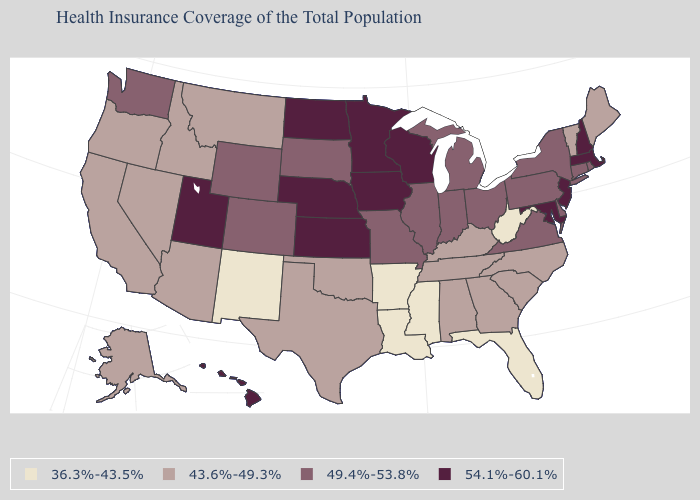What is the value of Colorado?
Give a very brief answer. 49.4%-53.8%. Which states have the lowest value in the South?
Short answer required. Arkansas, Florida, Louisiana, Mississippi, West Virginia. What is the value of Hawaii?
Write a very short answer. 54.1%-60.1%. What is the value of Delaware?
Quick response, please. 49.4%-53.8%. Does Georgia have the same value as Alaska?
Quick response, please. Yes. Is the legend a continuous bar?
Quick response, please. No. Does the first symbol in the legend represent the smallest category?
Quick response, please. Yes. Name the states that have a value in the range 49.4%-53.8%?
Keep it brief. Colorado, Connecticut, Delaware, Illinois, Indiana, Michigan, Missouri, New York, Ohio, Pennsylvania, Rhode Island, South Dakota, Virginia, Washington, Wyoming. Does Pennsylvania have a higher value than Texas?
Be succinct. Yes. What is the value of Mississippi?
Short answer required. 36.3%-43.5%. How many symbols are there in the legend?
Keep it brief. 4. What is the value of New York?
Short answer required. 49.4%-53.8%. What is the value of Indiana?
Keep it brief. 49.4%-53.8%. Does Mississippi have the lowest value in the South?
Write a very short answer. Yes. Does Texas have the lowest value in the USA?
Short answer required. No. 